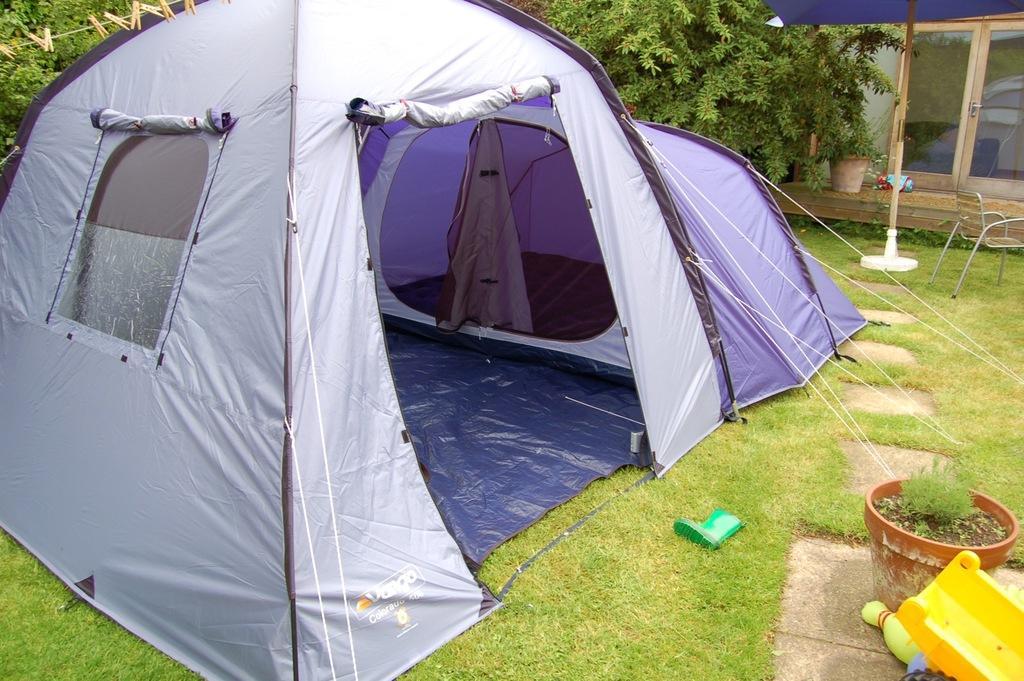Can you describe this image briefly? In this image we can see the camping tent. We can also see the cloth hanging clips to the rope. Image also consists of playing toys, grass, flower pots, trees and also the chair. We can also see the door and the wall. 